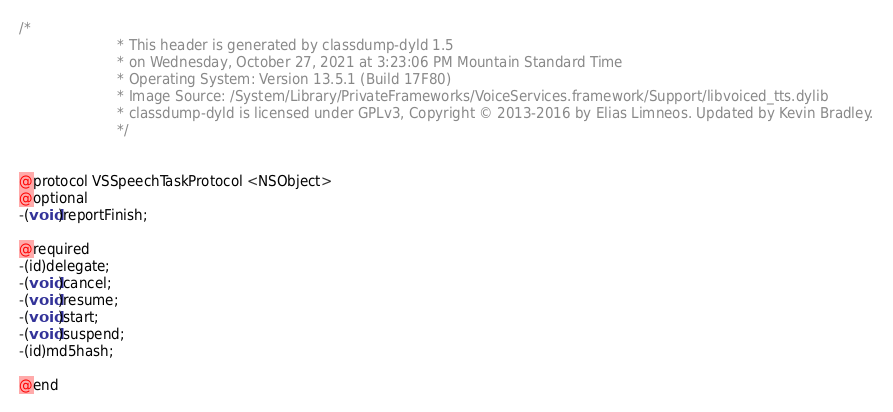Convert code to text. <code><loc_0><loc_0><loc_500><loc_500><_C_>/*
                       * This header is generated by classdump-dyld 1.5
                       * on Wednesday, October 27, 2021 at 3:23:06 PM Mountain Standard Time
                       * Operating System: Version 13.5.1 (Build 17F80)
                       * Image Source: /System/Library/PrivateFrameworks/VoiceServices.framework/Support/libvoiced_tts.dylib
                       * classdump-dyld is licensed under GPLv3, Copyright © 2013-2016 by Elias Limneos. Updated by Kevin Bradley.
                       */


@protocol VSSpeechTaskProtocol <NSObject>
@optional
-(void)reportFinish;

@required
-(id)delegate;
-(void)cancel;
-(void)resume;
-(void)start;
-(void)suspend;
-(id)md5hash;

@end

</code> 